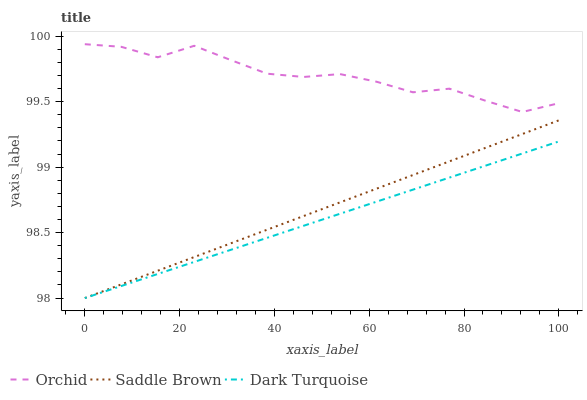Does Dark Turquoise have the minimum area under the curve?
Answer yes or no. Yes. Does Orchid have the maximum area under the curve?
Answer yes or no. Yes. Does Saddle Brown have the minimum area under the curve?
Answer yes or no. No. Does Saddle Brown have the maximum area under the curve?
Answer yes or no. No. Is Saddle Brown the smoothest?
Answer yes or no. Yes. Is Orchid the roughest?
Answer yes or no. Yes. Is Orchid the smoothest?
Answer yes or no. No. Is Saddle Brown the roughest?
Answer yes or no. No. Does Dark Turquoise have the lowest value?
Answer yes or no. Yes. Does Orchid have the lowest value?
Answer yes or no. No. Does Orchid have the highest value?
Answer yes or no. Yes. Does Saddle Brown have the highest value?
Answer yes or no. No. Is Saddle Brown less than Orchid?
Answer yes or no. Yes. Is Orchid greater than Saddle Brown?
Answer yes or no. Yes. Does Saddle Brown intersect Dark Turquoise?
Answer yes or no. Yes. Is Saddle Brown less than Dark Turquoise?
Answer yes or no. No. Is Saddle Brown greater than Dark Turquoise?
Answer yes or no. No. Does Saddle Brown intersect Orchid?
Answer yes or no. No. 